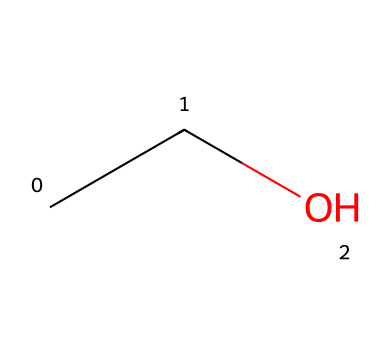What is the molecular formula of this chemical? The SMILES representation "CCO" translates into a molecular formula by identifying the number of carbon (C), hydrogen (H), and oxygen (O) atoms present. There are 2 carbon atoms, 6 hydrogen atoms, and 1 oxygen atom, leading to the formula C2H6O.
Answer: C2H6O How many carbon atoms are in this structure? By examining the SMILES representation "CCO", each "C" represents a carbon atom. Counting them yields 2 carbon atoms.
Answer: 2 What type of alcohol is represented by this structure? The compound with the SMILES "CCO" corresponds to ethanol, which is a type of primary alcohol. Ethanol is well-known for its presence in alcoholic beverages.
Answer: ethanol What kind of functional group does this chemical contain? The SMILES "CCO" indicates the presence of an -OH (hydroxyl) group attached to a carbon. This functional group is characteristic of alcohols, specifically primary alcohols in the case of ethanol.
Answer: hydroxyl How many hydrogen atoms are bonded to carbon in this structure? In the representation "CCO", each carbon atom is bonded to hydrogen atoms to satisfy carbon's tetravalency. The first carbon is bonded to three hydrogens, and the second carbon is bonded to two hydrogens plus one oxygen. Thus, there are 5 hydrogen atoms bonded to carbon in total.
Answer: 5 Does this compound have any double bonds? In the SMILES "CCO", there are no double bonds present, as indicated by the lack of "=" signs in the representation. All connections are single bonds between the carbon and oxygen atoms.
Answer: no What physical state is ethanol typically found in at room temperature? Ethanol is known to be a liquid at room temperature due to its molecular structure and intermolecular forces. It remains in liquid form within the typical environmental conditions found in most settings.
Answer: liquid 